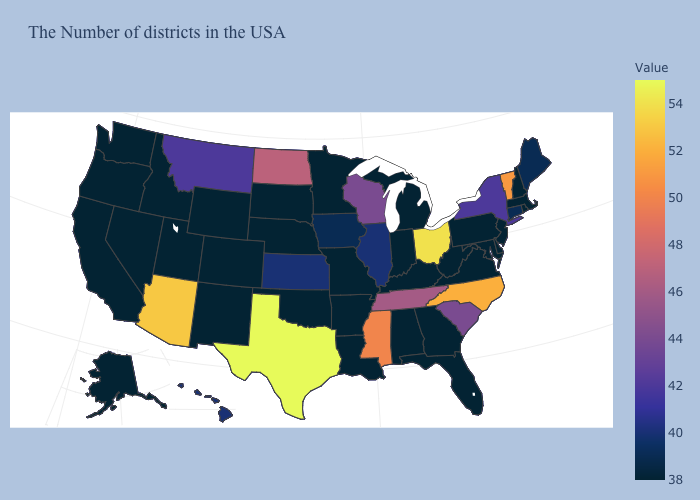Does Texas have the highest value in the USA?
Write a very short answer. Yes. Which states have the lowest value in the USA?
Answer briefly. Massachusetts, Rhode Island, New Hampshire, New Jersey, Delaware, Maryland, Pennsylvania, Virginia, West Virginia, Florida, Georgia, Michigan, Kentucky, Indiana, Alabama, Louisiana, Missouri, Arkansas, Minnesota, Nebraska, Oklahoma, South Dakota, Wyoming, Colorado, New Mexico, Utah, Idaho, Nevada, California, Washington, Oregon, Alaska. Does Montana have the lowest value in the USA?
Keep it brief. No. Does the map have missing data?
Be succinct. No. Among the states that border Utah , does Colorado have the lowest value?
Write a very short answer. Yes. 